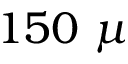Convert formula to latex. <formula><loc_0><loc_0><loc_500><loc_500>1 5 0 \mu</formula> 